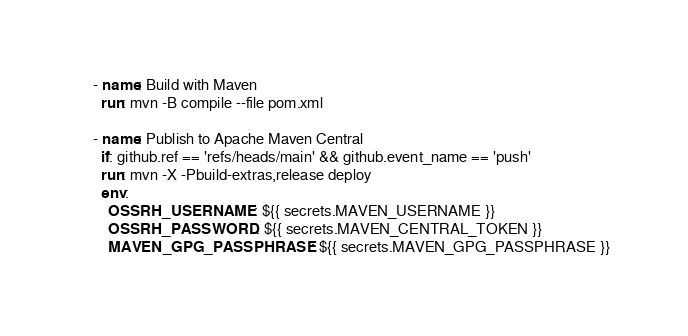<code> <loc_0><loc_0><loc_500><loc_500><_YAML_>    - name: Build with Maven
      run: mvn -B compile --file pom.xml

    - name: Publish to Apache Maven Central
      if: github.ref == 'refs/heads/main' && github.event_name == 'push' 
      run: mvn -X -Pbuild-extras,release deploy
      env:
        OSSRH_USERNAME: ${{ secrets.MAVEN_USERNAME }}
        OSSRH_PASSWORD: ${{ secrets.MAVEN_CENTRAL_TOKEN }}
        MAVEN_GPG_PASSPHRASE: ${{ secrets.MAVEN_GPG_PASSPHRASE }}
</code> 